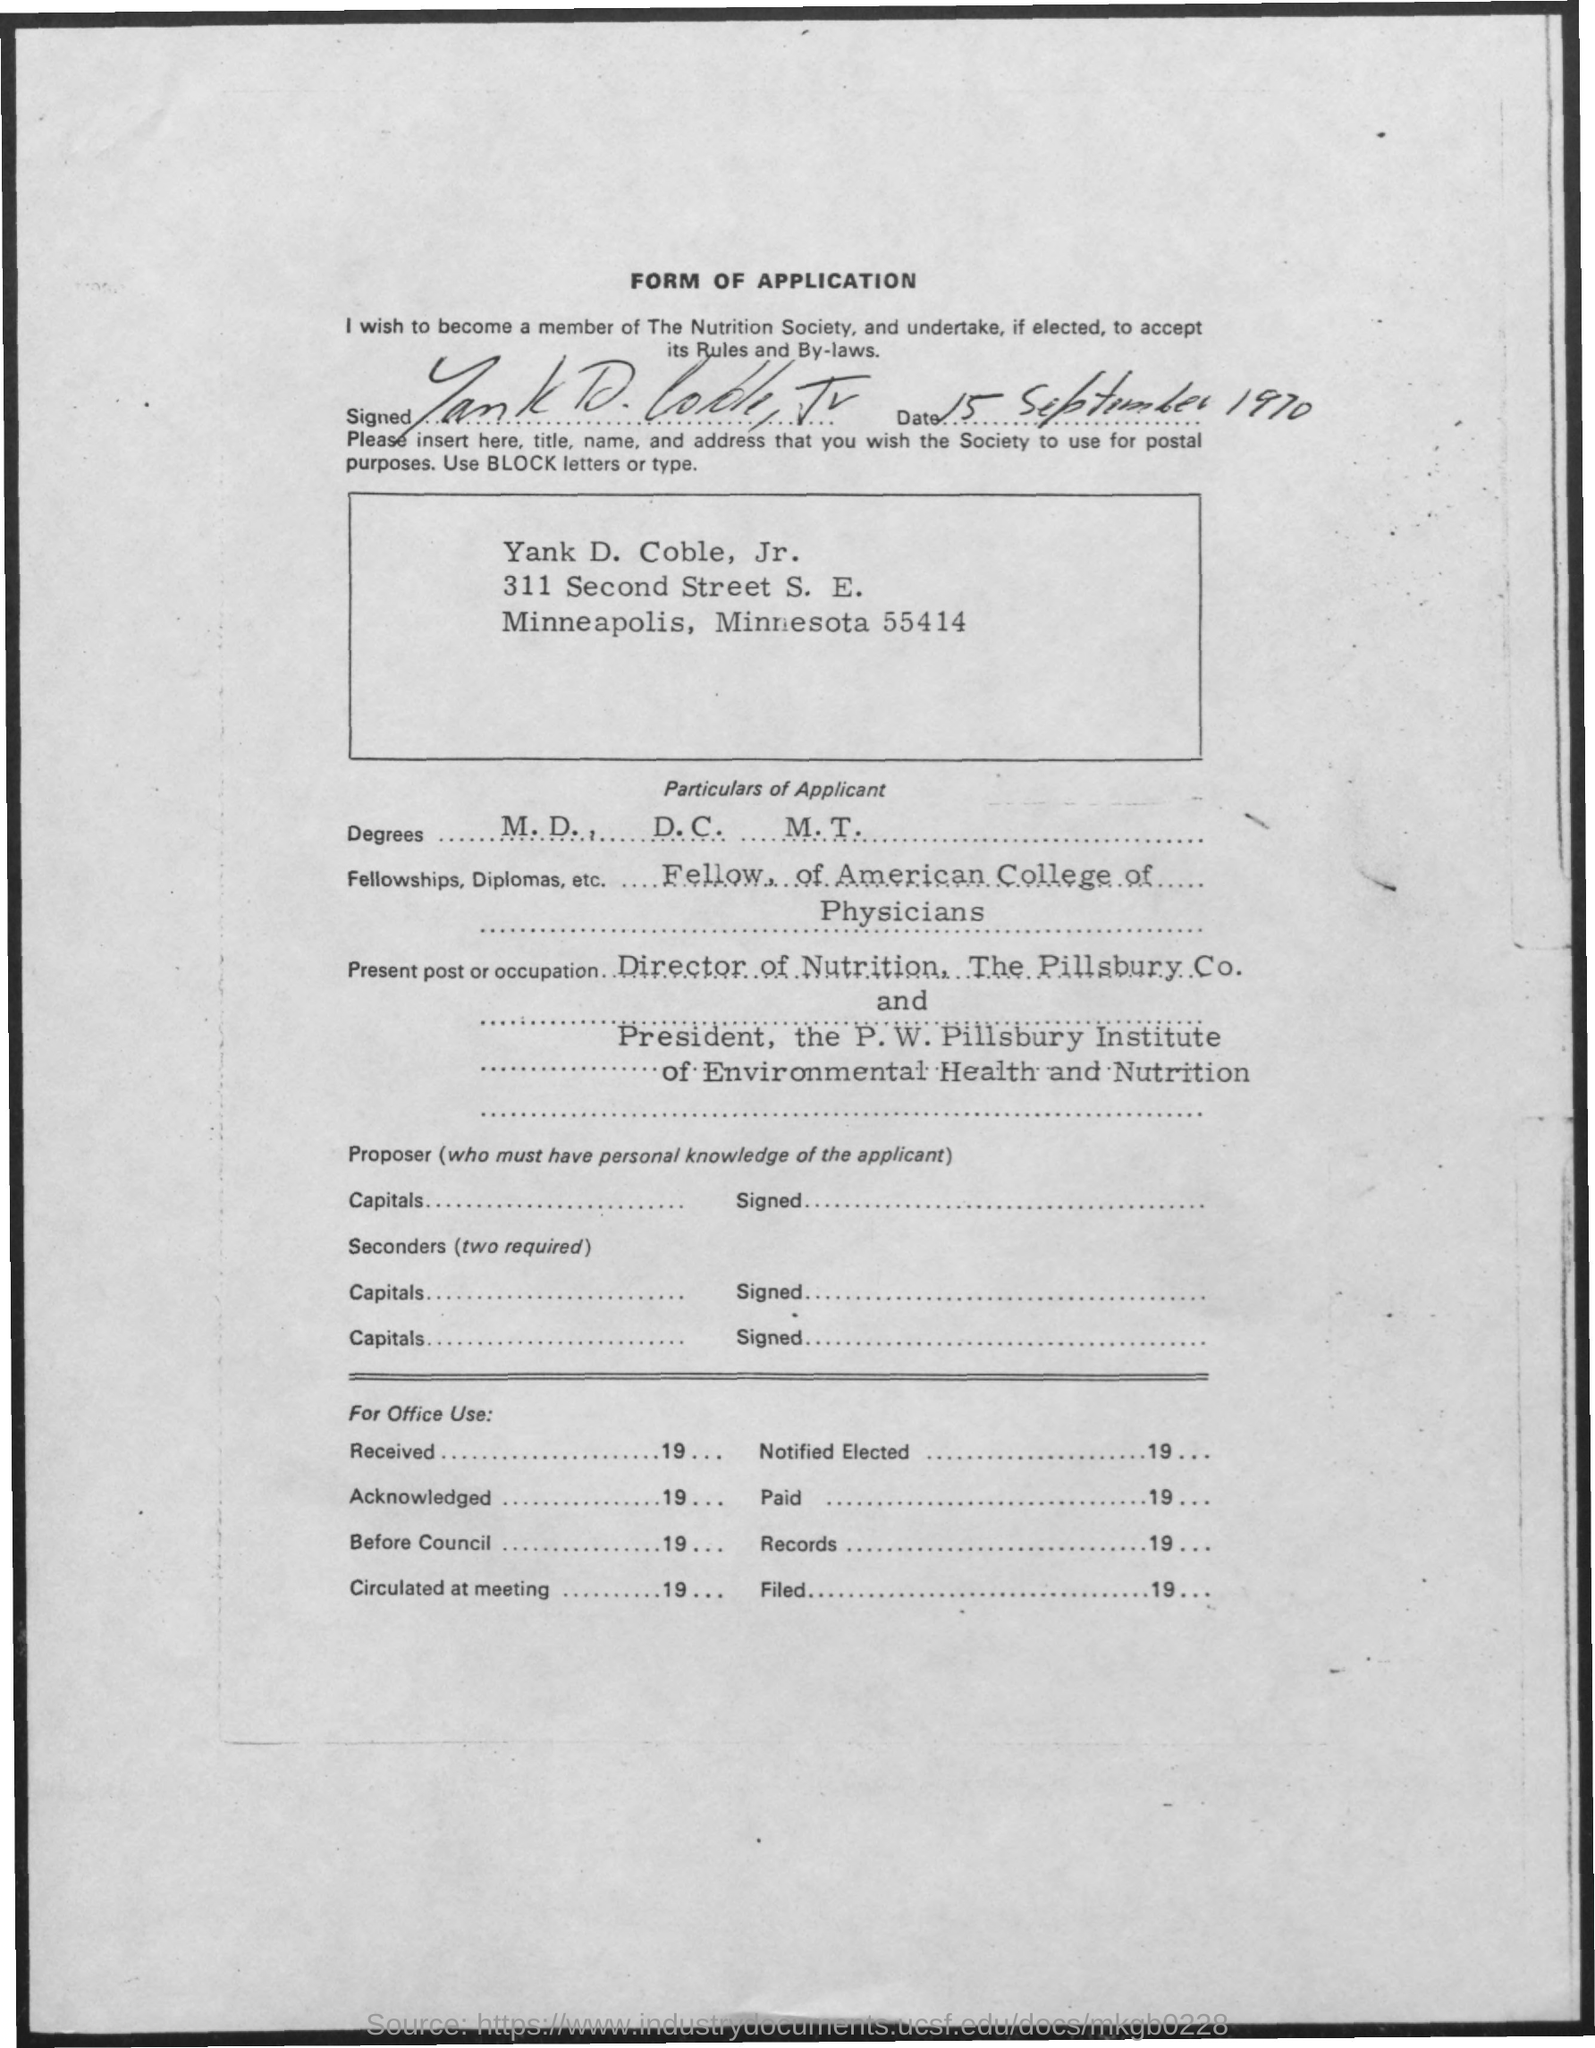What are the names of degrees mentioned ?
Keep it short and to the point. M.D. , D.C. , M.T. What is the date mentioned ?
Make the answer very short. 15 september 1970. What are the fellowships , diplomas etc mentioned in the given form ?
Provide a succinct answer. Fellow, of american college of physicians. 